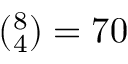<formula> <loc_0><loc_0><loc_500><loc_500>( _ { 4 } ^ { 8 } ) = 7 0</formula> 